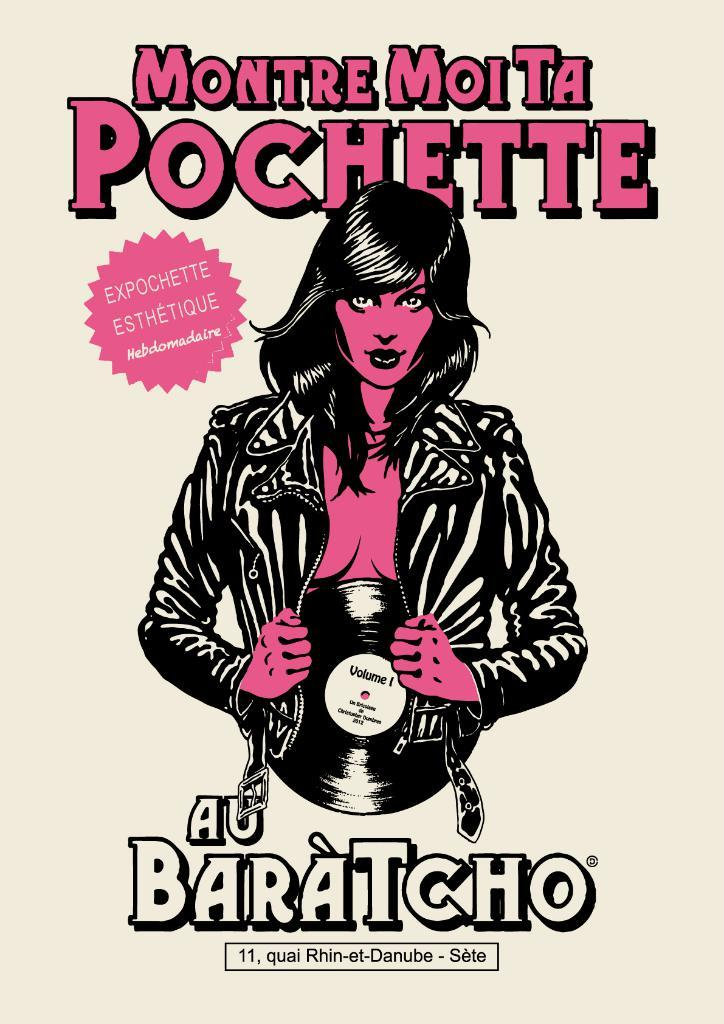What is the main object in the image? There is a poster in the image. What is shown on the poster? There is a lady depicted on the poster. What else can be seen on the poster besides the lady? There is text present on the poster. What type of pickle is being sold at the zoo in the image? There is no zoo or pickle present in the image; it only features a poster with a lady and text. 